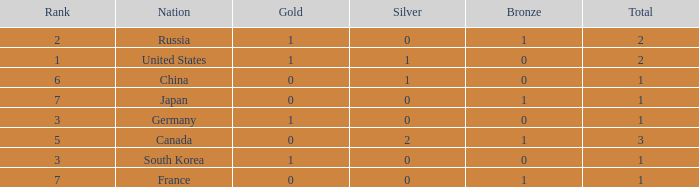Which Bronze has a Rank of 3, and a Silver larger than 0? None. 